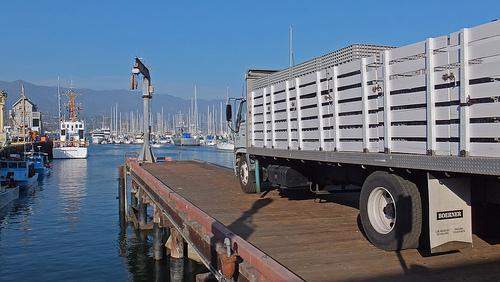Describe the scenery and atmosphere of the image in a poetic manner. A serene oceanic scene unfolds as a stately grey lorry rests on a pier, surrounded by the calm embrace of waters holding secure docked boats, and mountains whispering from the distance. Give a brief overview of the image focusing on the central point. Centered around a grey truck parked on a pier, the image showcases docked boats, a crane, a grey building, calm ocean water, and majestic mountains in the background. Write a brief overview of the main subject and the environment in the image. The image features a grey truck parked on a pier amidst calm ocean water, nearby docked boats, a crane, a building, and a stunning mountain range in the background. Mention the primary focus of the image and the main elements present around it. The primary focus is a grey lorry parked on a dock, surrounded by docked boats, a crane, a two-story grey building, and a scenic mountain range. In a single sentence, describe the subject of the image along with the environment. A grey lorry parked on a pier loaded with docked boats under the watchful gaze of distant mountains. Describe the main setting of the image and the objects that can be seen. In a peaceful coastal scene, a grey truck is parked on a pier surrounded by several docked boats, a crane, a building, and mountains in the distance. Provide a short description of what can be seen in the image with a focus on the primary subject. The image mainly shows a parked grey truck on a pier, surrounded by calm ocean water, various docked boats, a crane, a building, and a mountain range in the background. Explain the most prominent object of the scene and its surroundings in the image. A grey truck takes the center stage, parked on a pier, while docked boats and a crane are seen nearby, with a distant mountain range completing the picturesque view. Summarize the scene in the image, highlighting the primary object and the setting. A calm ocean scene with a grey truck parked on a pier, accompanied by docked boats, a crane, a building, and a breathtaking mountain range in the distance. Provide a brief description of the main scene in the image. A large grey truck is parked on a pier near calm ocean water, with several docked boats and a distant mountain range in the background. Does the pier have a wooden staircase leading up to it? No, it's not mentioned in the image. 